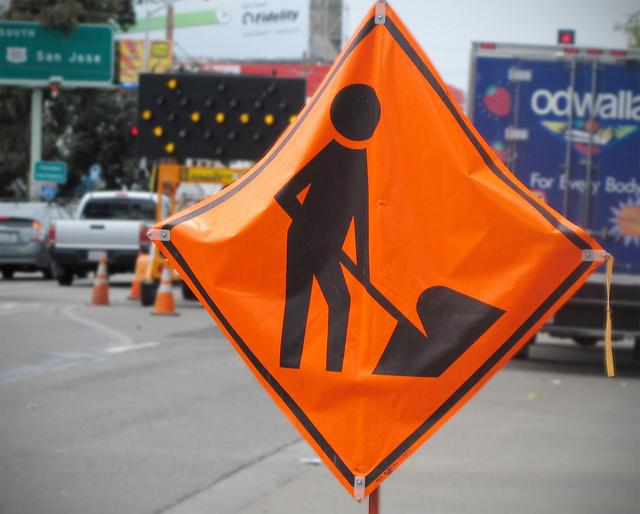What does the orange sign alert drivers of? Please explain your reasoning. construction. The sign is used to showcase visually that work is being done by having a silhouette of a man digging. 